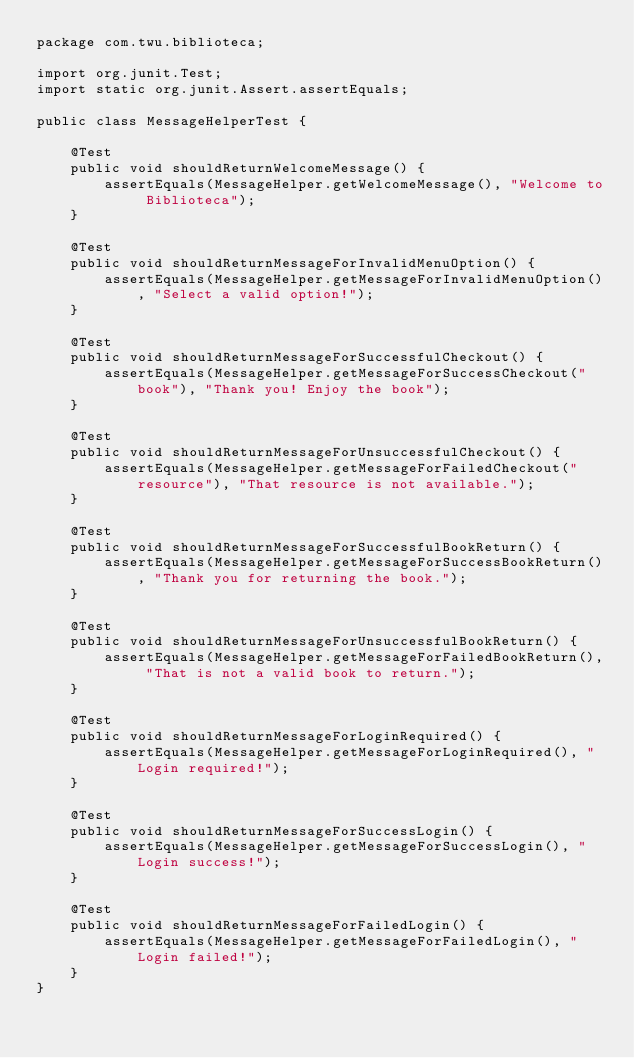Convert code to text. <code><loc_0><loc_0><loc_500><loc_500><_Java_>package com.twu.biblioteca;

import org.junit.Test;
import static org.junit.Assert.assertEquals;

public class MessageHelperTest {

    @Test
    public void shouldReturnWelcomeMessage() {
        assertEquals(MessageHelper.getWelcomeMessage(), "Welcome to Biblioteca");
    }

    @Test
    public void shouldReturnMessageForInvalidMenuOption() {
        assertEquals(MessageHelper.getMessageForInvalidMenuOption(), "Select a valid option!");
    }

    @Test
    public void shouldReturnMessageForSuccessfulCheckout() {
        assertEquals(MessageHelper.getMessageForSuccessCheckout("book"), "Thank you! Enjoy the book");
    }

    @Test
    public void shouldReturnMessageForUnsuccessfulCheckout() {
        assertEquals(MessageHelper.getMessageForFailedCheckout("resource"), "That resource is not available.");
    }

    @Test
    public void shouldReturnMessageForSuccessfulBookReturn() {
        assertEquals(MessageHelper.getMessageForSuccessBookReturn(), "Thank you for returning the book.");
    }

    @Test
    public void shouldReturnMessageForUnsuccessfulBookReturn() {
        assertEquals(MessageHelper.getMessageForFailedBookReturn(), "That is not a valid book to return.");
    }

    @Test
    public void shouldReturnMessageForLoginRequired() {
        assertEquals(MessageHelper.getMessageForLoginRequired(), "Login required!");
    }

    @Test
    public void shouldReturnMessageForSuccessLogin() {
        assertEquals(MessageHelper.getMessageForSuccessLogin(), "Login success!");
    }

    @Test
    public void shouldReturnMessageForFailedLogin() {
        assertEquals(MessageHelper.getMessageForFailedLogin(), "Login failed!");
    }
}
</code> 